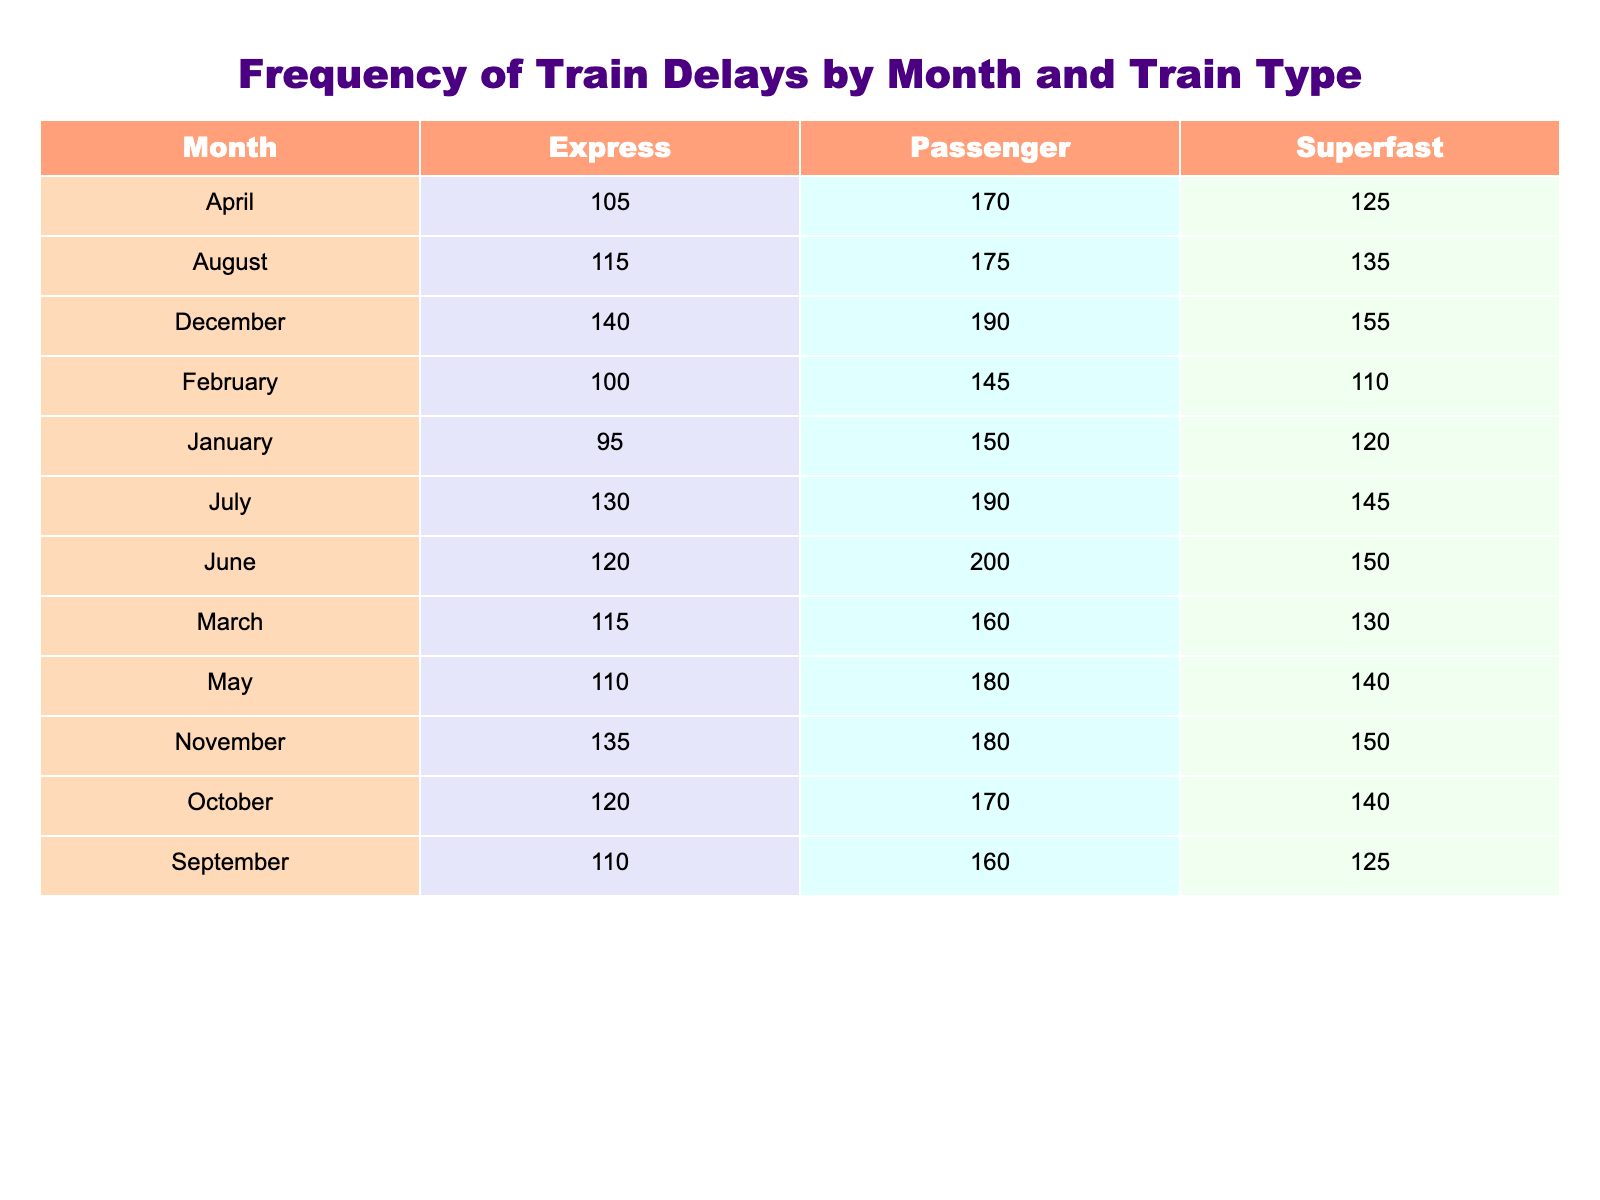What is the total number of train delays for Superfast trains in June? In June, the number of delays for Superfast trains is given as 150. There are no other entries for Superfast trains in June, so the total is simply 150.
Answer: 150 Which month had the highest number of delays for Passenger trains? The highest number of delays for Passenger trains is found in December, with a count of 190 delays. No other month exceeds this number for Passenger trains.
Answer: December What is the total number of delays for all train types in July? To find the total delays in July, we add the delays for Superfast (145), Express (130), and Passenger (190) trains: 145 + 130 + 190 = 465.
Answer: 465 In which month is the delay for Express trains greater than 100? In the months of March, April, May, July, November, and December, the delays for Express trains are all greater than 100. By checking these months in the table, we see that all their respective delays exceed 100.
Answer: March, April, May, July, November, December What is the average number of delays for all train types in August? For August, we gather the number of delays for each train type: Superfast (135), Express (115), and Passenger (175). The sum is 135 + 115 + 175 = 425, and there are three train types, so we compute the average: 425 / 3 = 141.67.
Answer: 141.67 Was the number of delays for Superfast trains in November greater than in October? In November, Superfast trains had 150 delays, while in October there were 140. Since 150 is greater than 140, the answer is yes.
Answer: Yes What is the difference in delays for Passenger trains between March and May? For Passenger trains, March had 160 delays and May had 180 delays. To find the difference, we subtract March from May: 180 - 160 = 20.
Answer: 20 Is the total number of delays for Passenger trains in December more than the total for Superfast trains in the same month? For Passenger trains in December, there were 190 delays, and for Superfast trains, there were 155 delays. The comparison shows that 190 is greater than 155, making the answer yes.
Answer: Yes Which train type had the most delays on average over the year? Calculate the average delays for each train type by summing the monthly delays and dividing by 12 (the number of months). For Superfast, the total is 1520; for Express, it is 1315; for Passenger, it is 1850. The averages are Superfast: 126.67, Express: 109.58, Passenger: 154.17. Since Passenger has the highest average, that is the train type with the most delays.
Answer: Passenger 